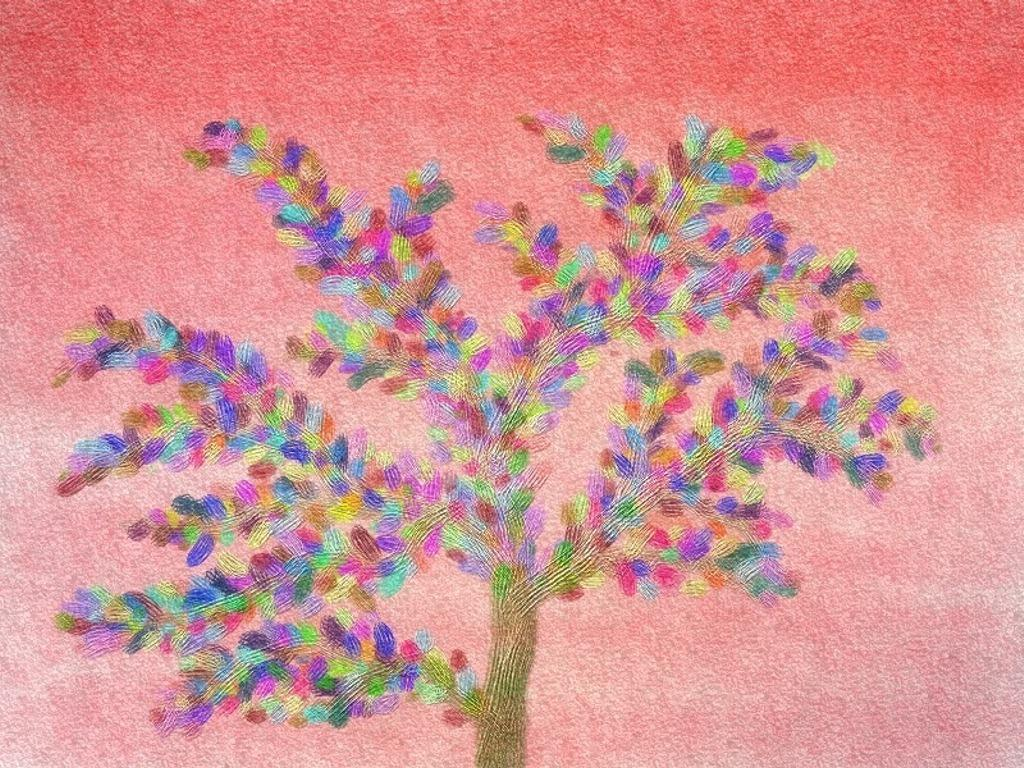What is the main subject of the painting in the image? There is a painting of a tree in the center of the image. What type of poison is depicted being poured onto the tree in the painting? There is no poison or any indication of poison in the painting; it features a tree. Is there a gun visible in the painting? There is no gun or any indication of a gun in the painting; it features a tree. 